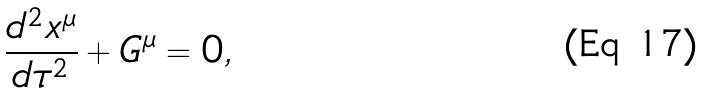<formula> <loc_0><loc_0><loc_500><loc_500>\frac { d ^ { 2 } x ^ { \mu } } { d \tau ^ { 2 } } + G ^ { \mu } = 0 ,</formula> 